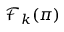<formula> <loc_0><loc_0><loc_500><loc_500>{ \mathcal { F } } _ { k } ( \pi )</formula> 